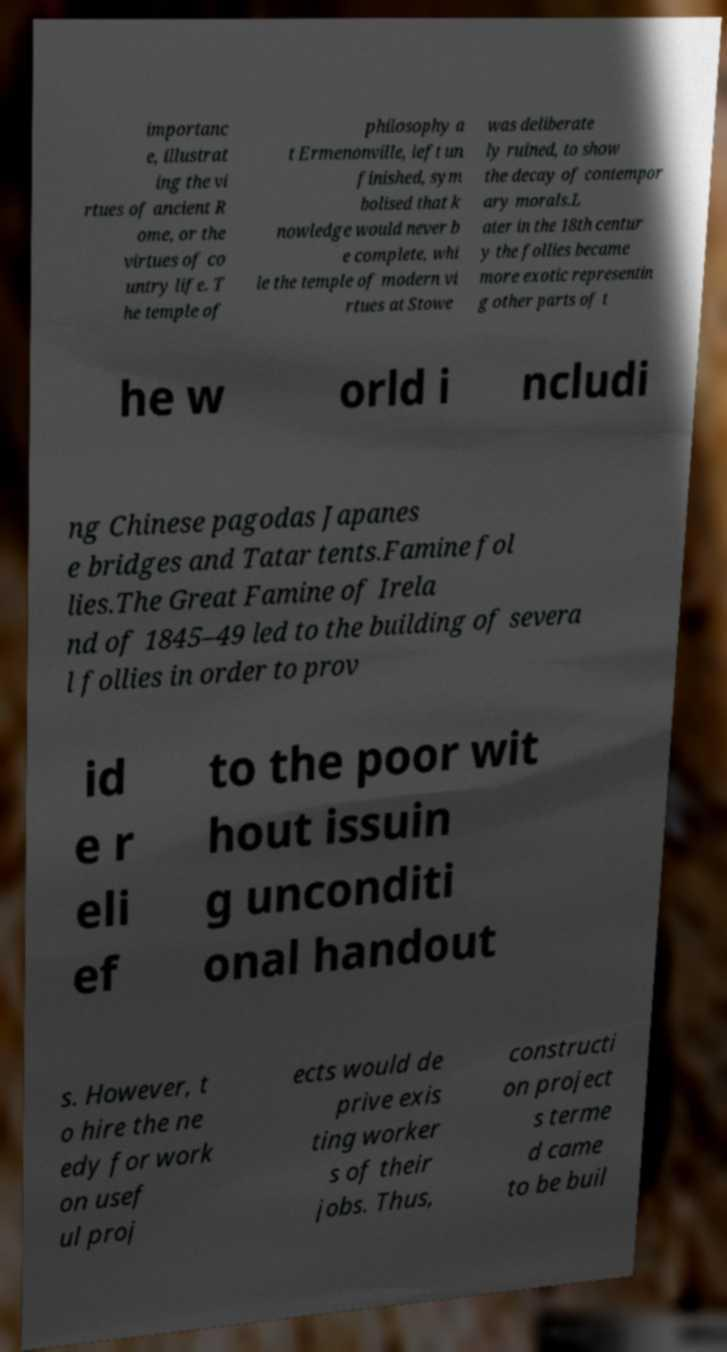There's text embedded in this image that I need extracted. Can you transcribe it verbatim? importanc e, illustrat ing the vi rtues of ancient R ome, or the virtues of co untry life. T he temple of philosophy a t Ermenonville, left un finished, sym bolised that k nowledge would never b e complete, whi le the temple of modern vi rtues at Stowe was deliberate ly ruined, to show the decay of contempor ary morals.L ater in the 18th centur y the follies became more exotic representin g other parts of t he w orld i ncludi ng Chinese pagodas Japanes e bridges and Tatar tents.Famine fol lies.The Great Famine of Irela nd of 1845–49 led to the building of severa l follies in order to prov id e r eli ef to the poor wit hout issuin g unconditi onal handout s. However, t o hire the ne edy for work on usef ul proj ects would de prive exis ting worker s of their jobs. Thus, constructi on project s terme d came to be buil 